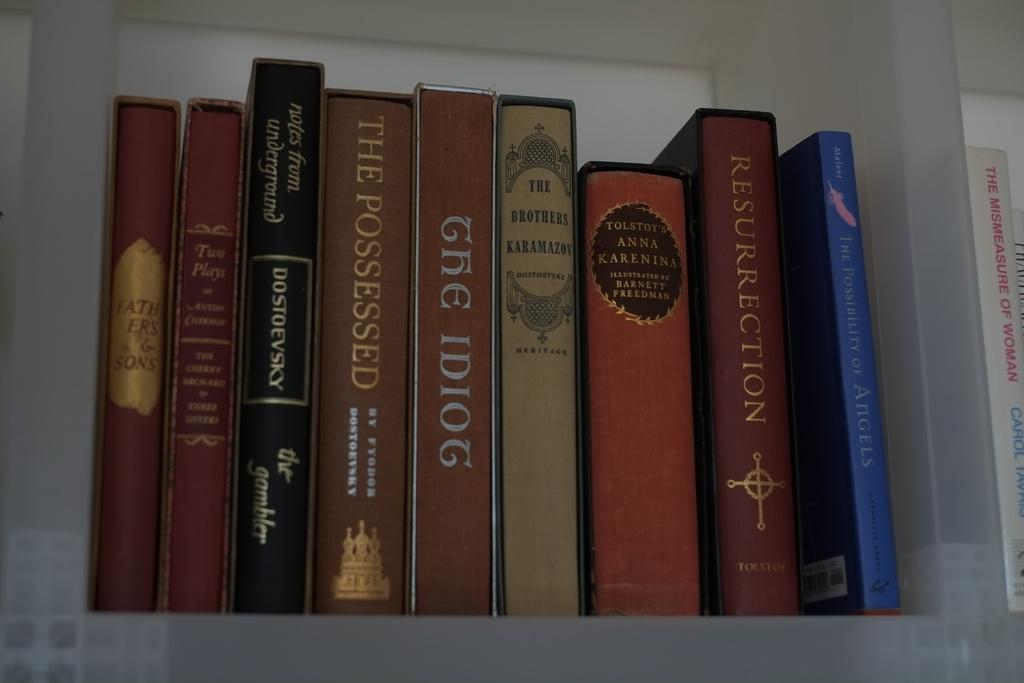<image>
Present a compact description of the photo's key features. books stacked o a shelf include The Idiot and Anna Karenina 